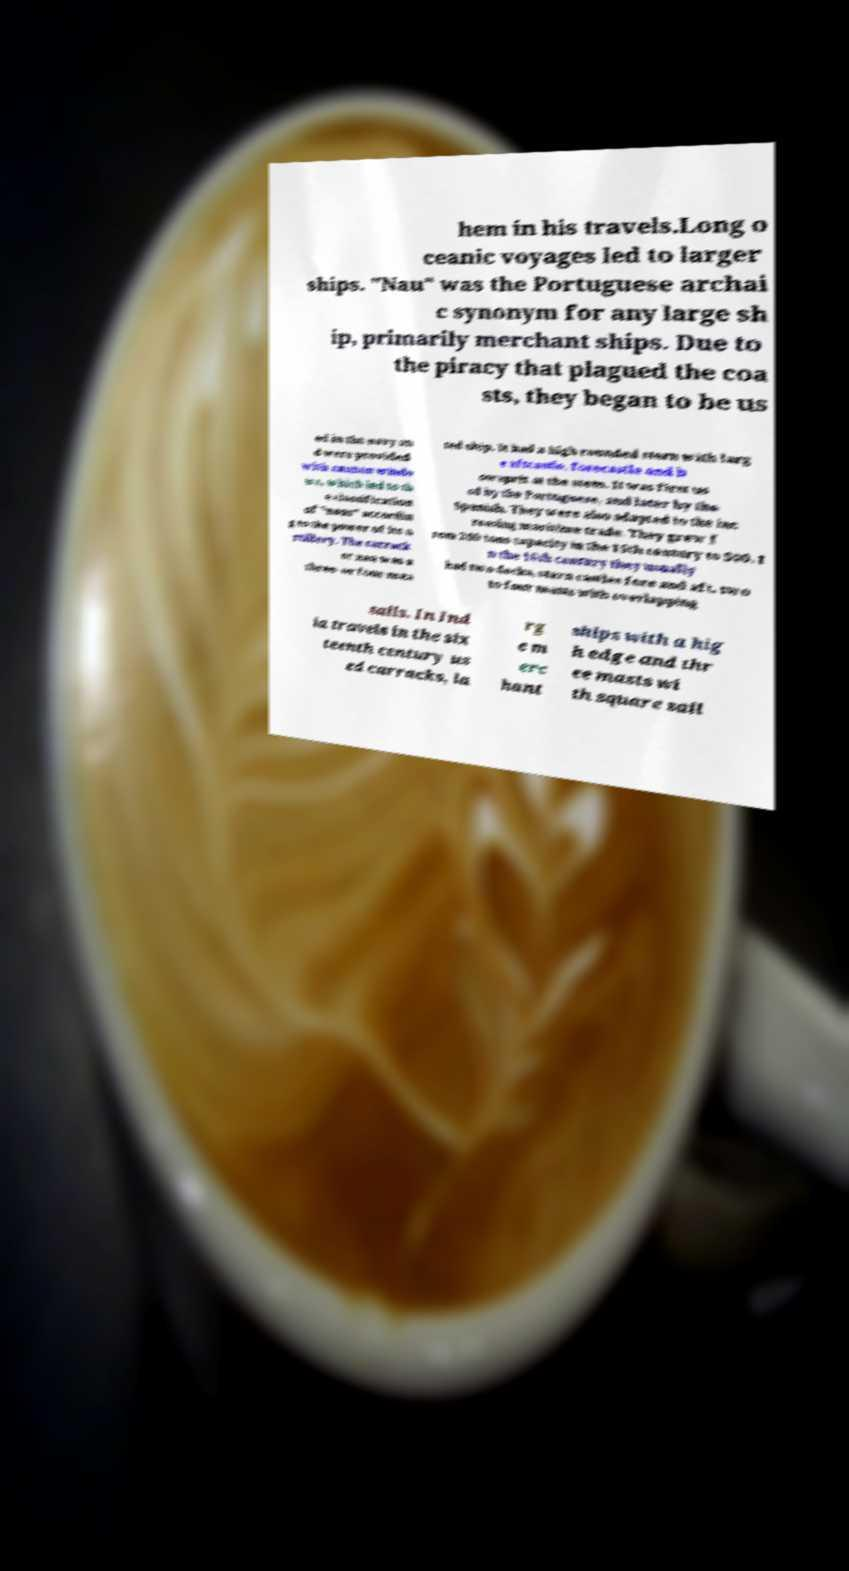Please identify and transcribe the text found in this image. hem in his travels.Long o ceanic voyages led to larger ships. "Nau" was the Portuguese archai c synonym for any large sh ip, primarily merchant ships. Due to the piracy that plagued the coa sts, they began to be us ed in the navy an d were provided with cannon windo ws, which led to th e classification of "naus" accordin g to the power of its a rtillery. The carrack or nau was a three- or four-mas ted ship. It had a high rounded stern with larg e aftcastle, forecastle and b owsprit at the stem. It was first us ed by the Portuguese, and later by the Spanish. They were also adapted to the inc reasing maritime trade. They grew f rom 200 tons capacity in the 15th century to 500. I n the 16th century they usually had two decks, stern castles fore and aft, two to four masts with overlapping sails. In Ind ia travels in the six teenth century us ed carracks, la rg e m erc hant ships with a hig h edge and thr ee masts wi th square sail 